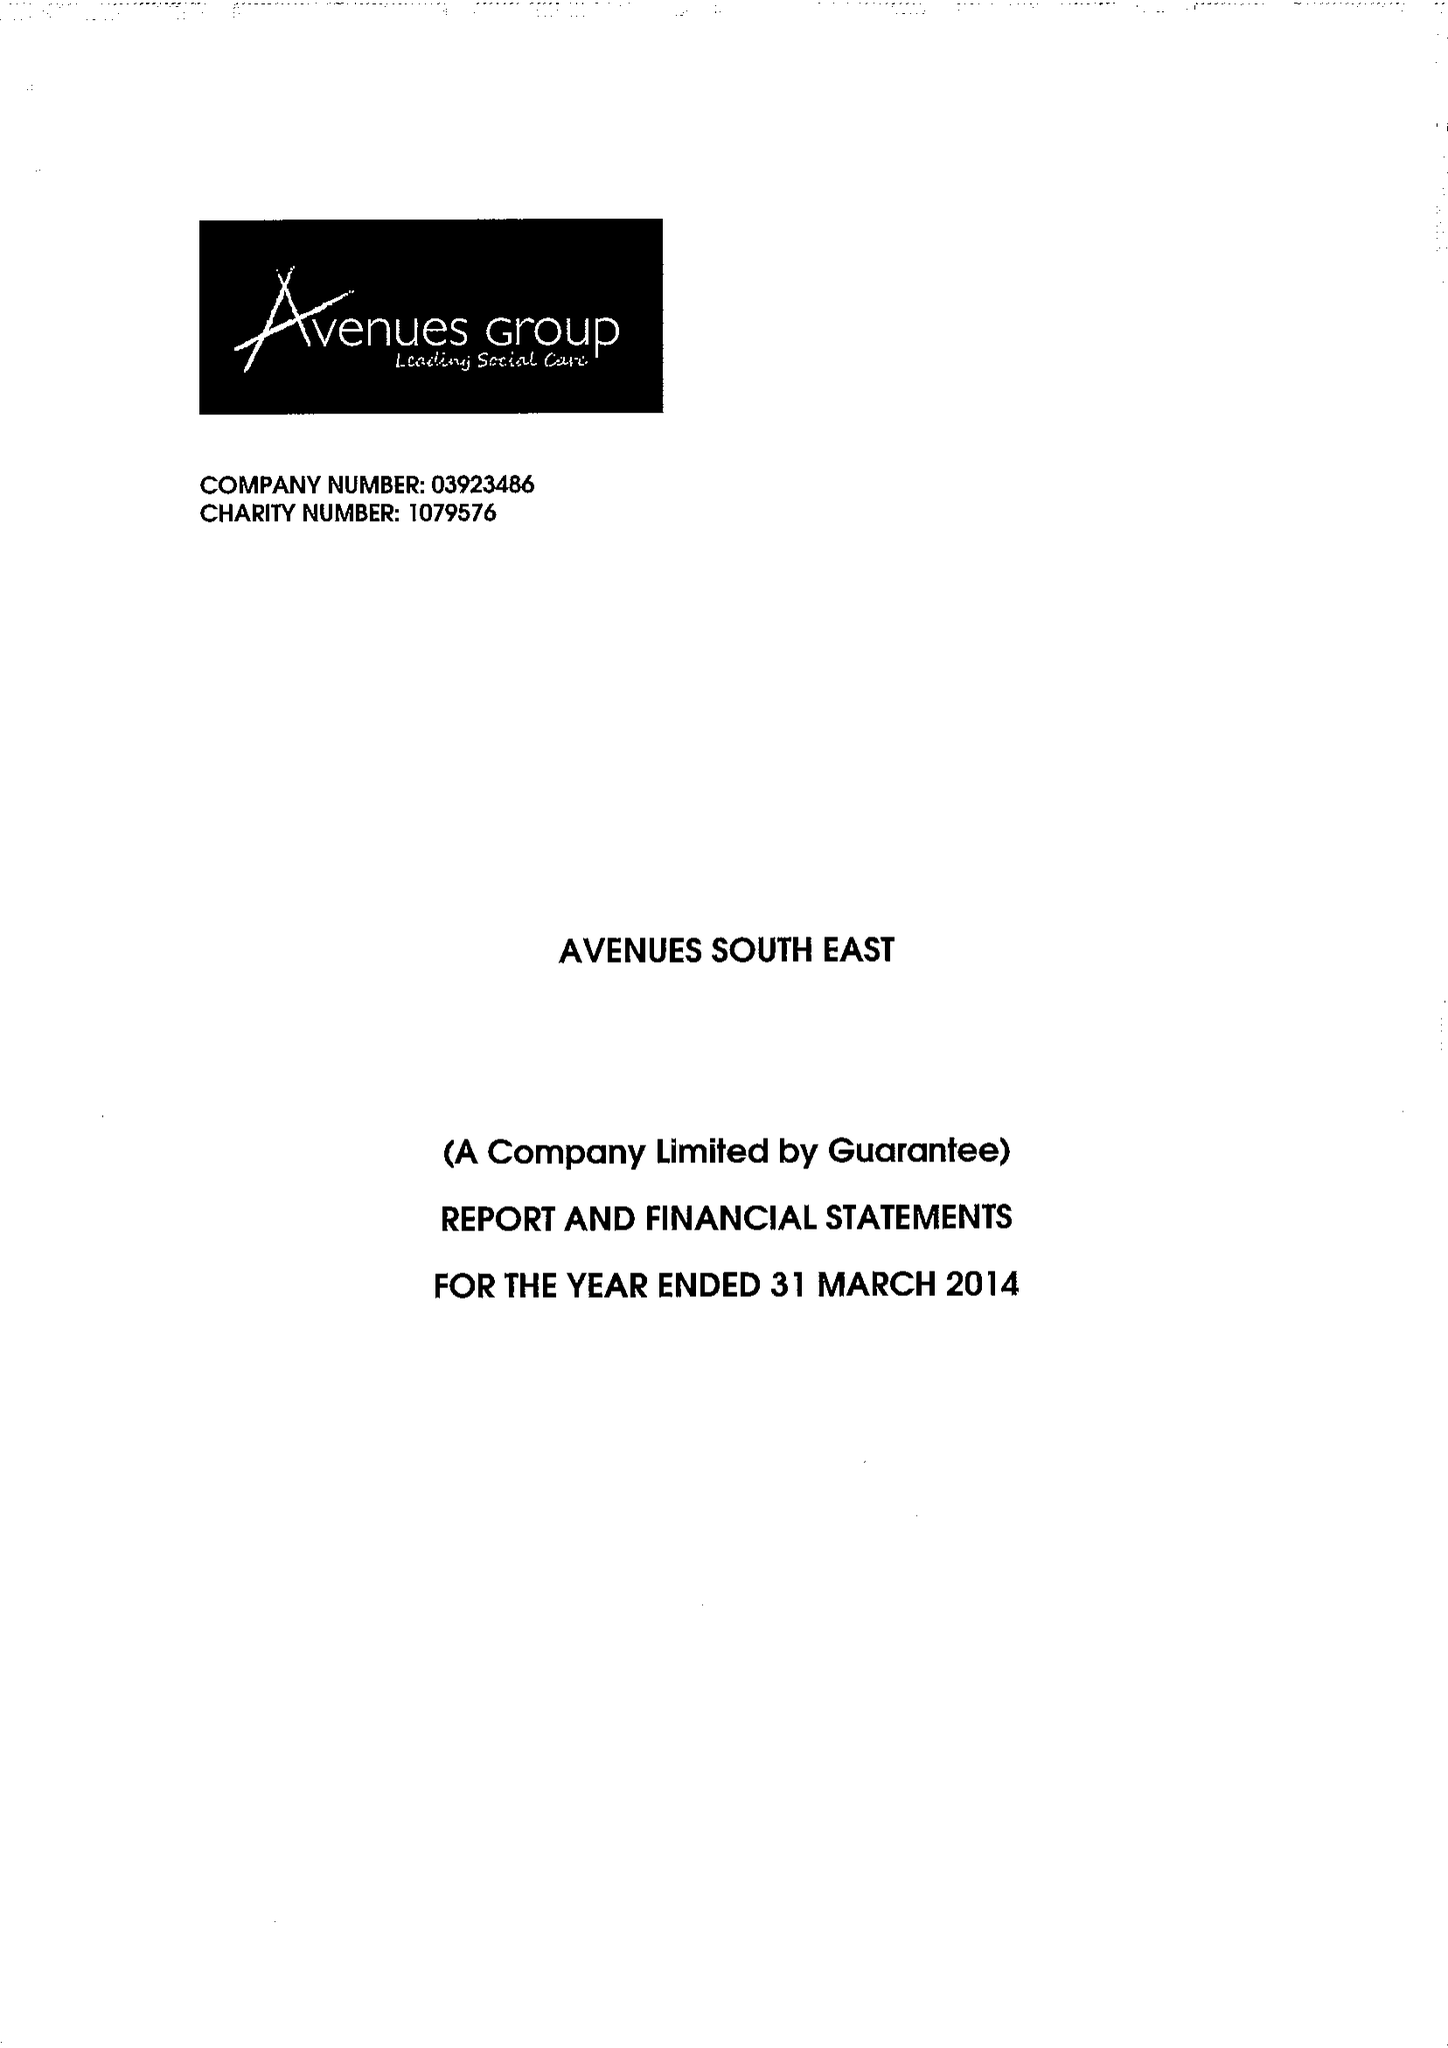What is the value for the spending_annually_in_british_pounds?
Answer the question using a single word or phrase. 13669247.00 